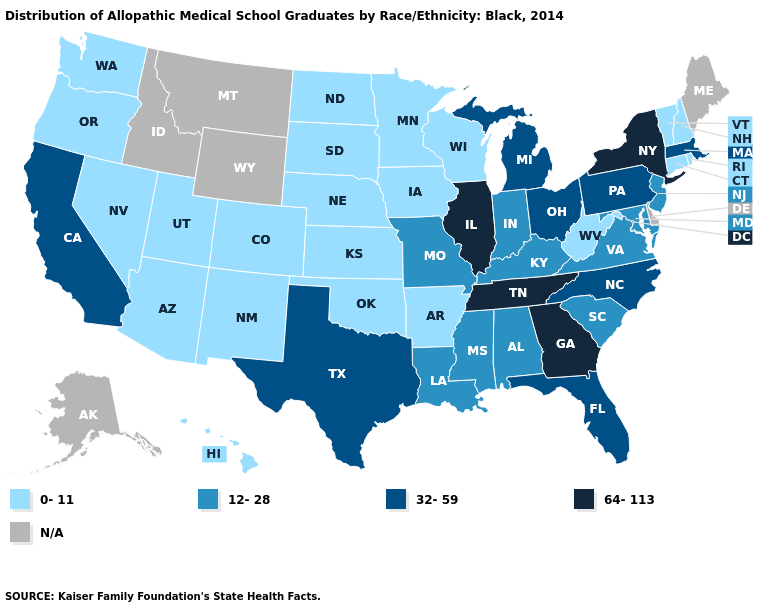Which states have the lowest value in the South?
Quick response, please. Arkansas, Oklahoma, West Virginia. What is the value of Montana?
Answer briefly. N/A. Does the map have missing data?
Give a very brief answer. Yes. Does Arizona have the highest value in the West?
Give a very brief answer. No. Does West Virginia have the highest value in the USA?
Keep it brief. No. Does Georgia have the highest value in the USA?
Concise answer only. Yes. Is the legend a continuous bar?
Quick response, please. No. Does the map have missing data?
Quick response, please. Yes. Does the map have missing data?
Keep it brief. Yes. What is the value of Colorado?
Write a very short answer. 0-11. Name the states that have a value in the range N/A?
Quick response, please. Alaska, Delaware, Idaho, Maine, Montana, Wyoming. What is the value of Massachusetts?
Answer briefly. 32-59. What is the value of Maryland?
Be succinct. 12-28. 